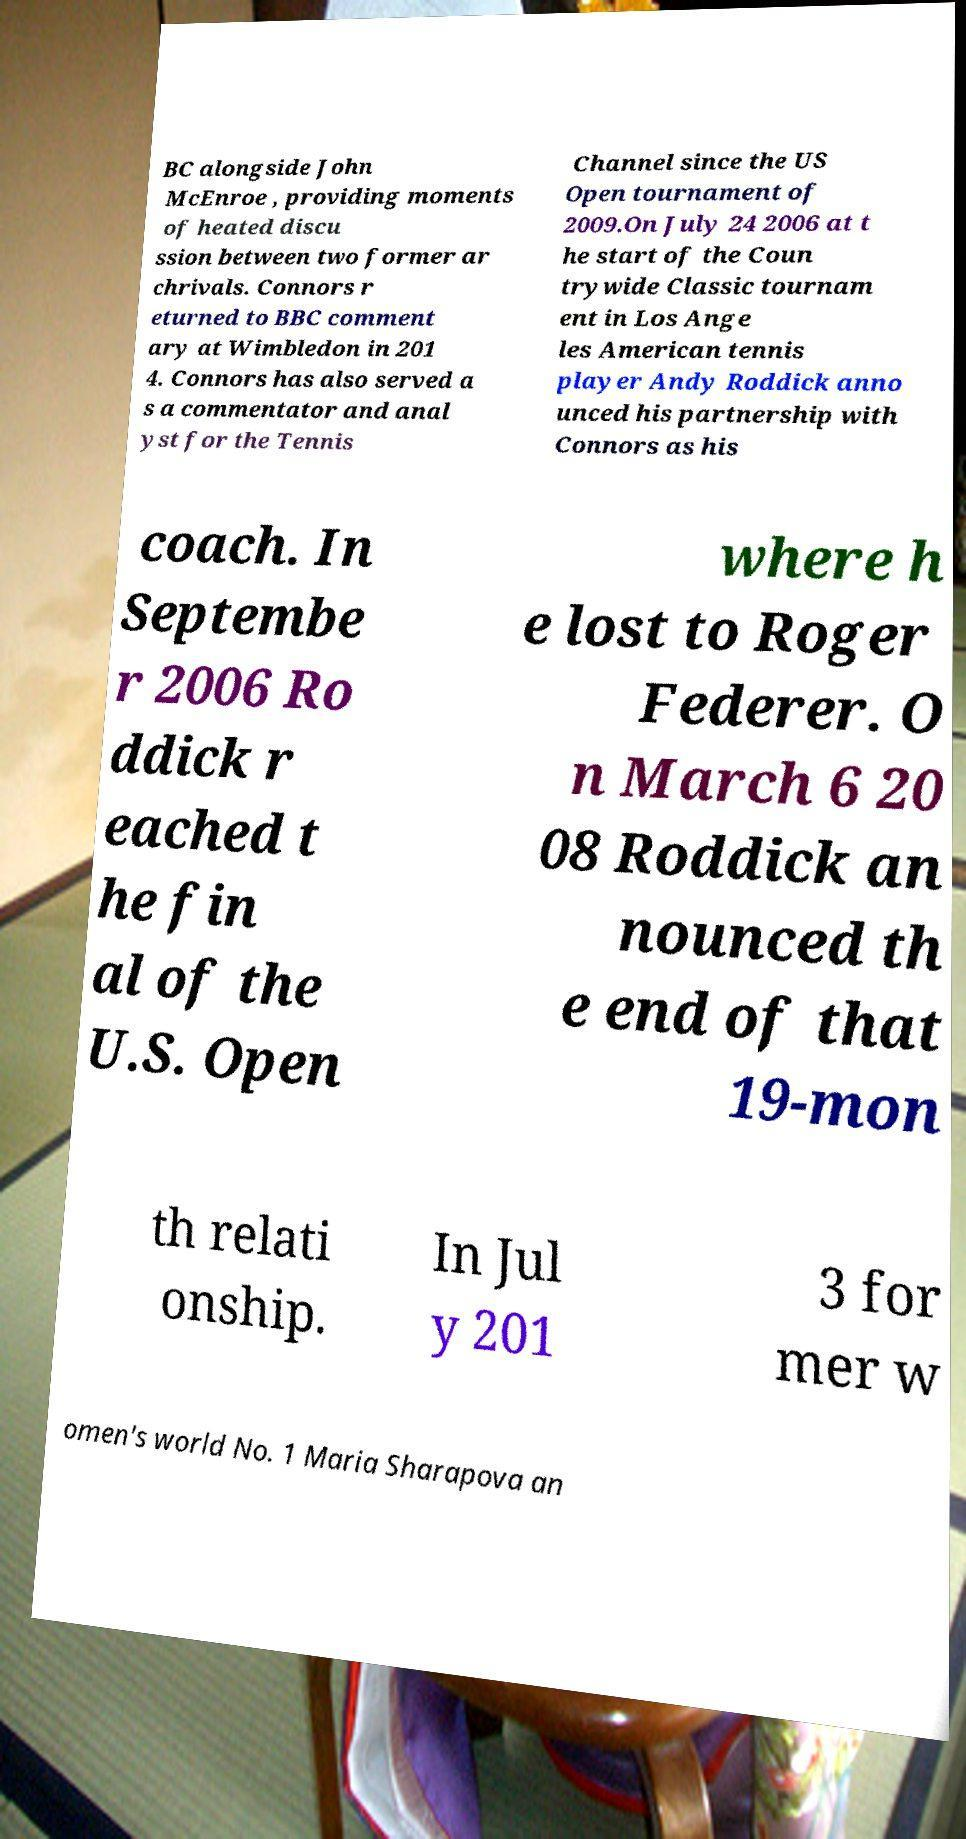What messages or text are displayed in this image? I need them in a readable, typed format. BC alongside John McEnroe , providing moments of heated discu ssion between two former ar chrivals. Connors r eturned to BBC comment ary at Wimbledon in 201 4. Connors has also served a s a commentator and anal yst for the Tennis Channel since the US Open tournament of 2009.On July 24 2006 at t he start of the Coun trywide Classic tournam ent in Los Ange les American tennis player Andy Roddick anno unced his partnership with Connors as his coach. In Septembe r 2006 Ro ddick r eached t he fin al of the U.S. Open where h e lost to Roger Federer. O n March 6 20 08 Roddick an nounced th e end of that 19-mon th relati onship. In Jul y 201 3 for mer w omen's world No. 1 Maria Sharapova an 